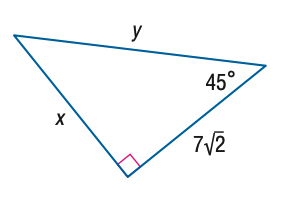Answer the mathemtical geometry problem and directly provide the correct option letter.
Question: Find y.
Choices: A: 7 B: 7 \sqrt { 2 } C: 14 D: 14 \sqrt { 2 } C 